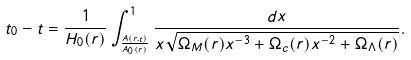Convert formula to latex. <formula><loc_0><loc_0><loc_500><loc_500>t _ { 0 } - t = \frac { 1 } { H _ { 0 } ( r ) } \int _ { \frac { A ( r , t ) } { A _ { 0 } ( r ) } } ^ { 1 } \frac { d x } { x \sqrt { \Omega _ { M } ( r ) x ^ { - 3 } + \Omega _ { c } ( r ) x ^ { - 2 } + \Omega _ { \Lambda } ( r ) } } .</formula> 